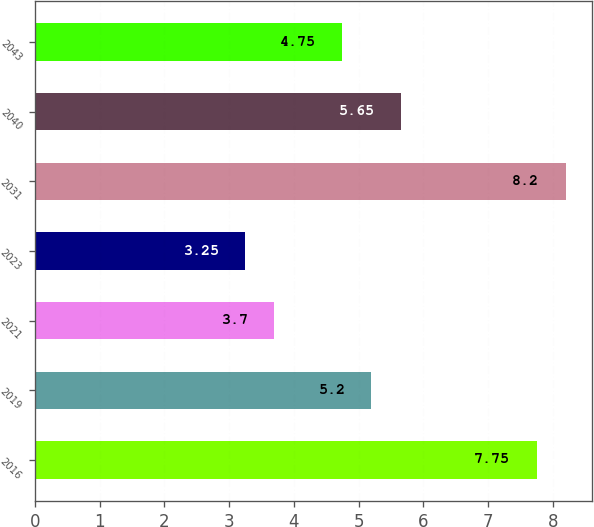Convert chart. <chart><loc_0><loc_0><loc_500><loc_500><bar_chart><fcel>2016<fcel>2019<fcel>2021<fcel>2023<fcel>2031<fcel>2040<fcel>2043<nl><fcel>7.75<fcel>5.2<fcel>3.7<fcel>3.25<fcel>8.2<fcel>5.65<fcel>4.75<nl></chart> 